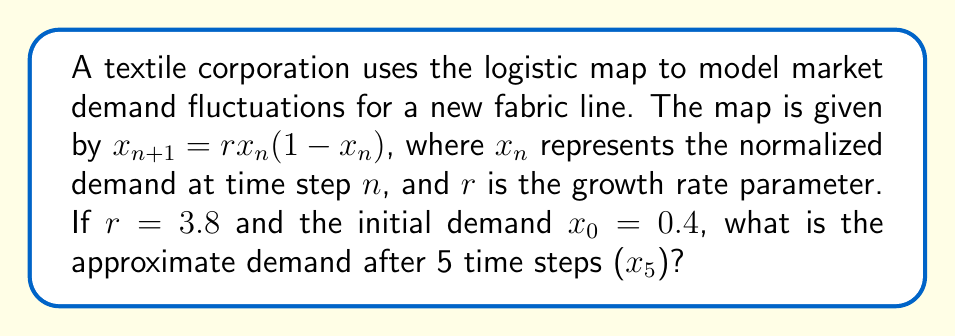Help me with this question. To solve this problem, we need to iterate the logistic map equation for 5 time steps:

1) First iteration ($n=0$ to $n=1$):
   $x_1 = 3.8 \cdot 0.4 \cdot (1-0.4) = 3.8 \cdot 0.4 \cdot 0.6 = 0.912$

2) Second iteration ($n=1$ to $n=2$):
   $x_2 = 3.8 \cdot 0.912 \cdot (1-0.912) = 3.8 \cdot 0.912 \cdot 0.088 = 0.3053376$

3) Third iteration ($n=2$ to $n=3$):
   $x_3 = 3.8 \cdot 0.3053376 \cdot (1-0.3053376) = 0.8066903$

4) Fourth iteration ($n=3$ to $n=4$):
   $x_4 = 3.8 \cdot 0.8066903 \cdot (1-0.8066903) = 0.5950599$

5) Fifth iteration ($n=4$ to $n=5$):
   $x_5 = 3.8 \cdot 0.5950599 \cdot (1-0.5950599) = 0.9151077$

The demand after 5 time steps is approximately 0.9151.
Answer: 0.9151 